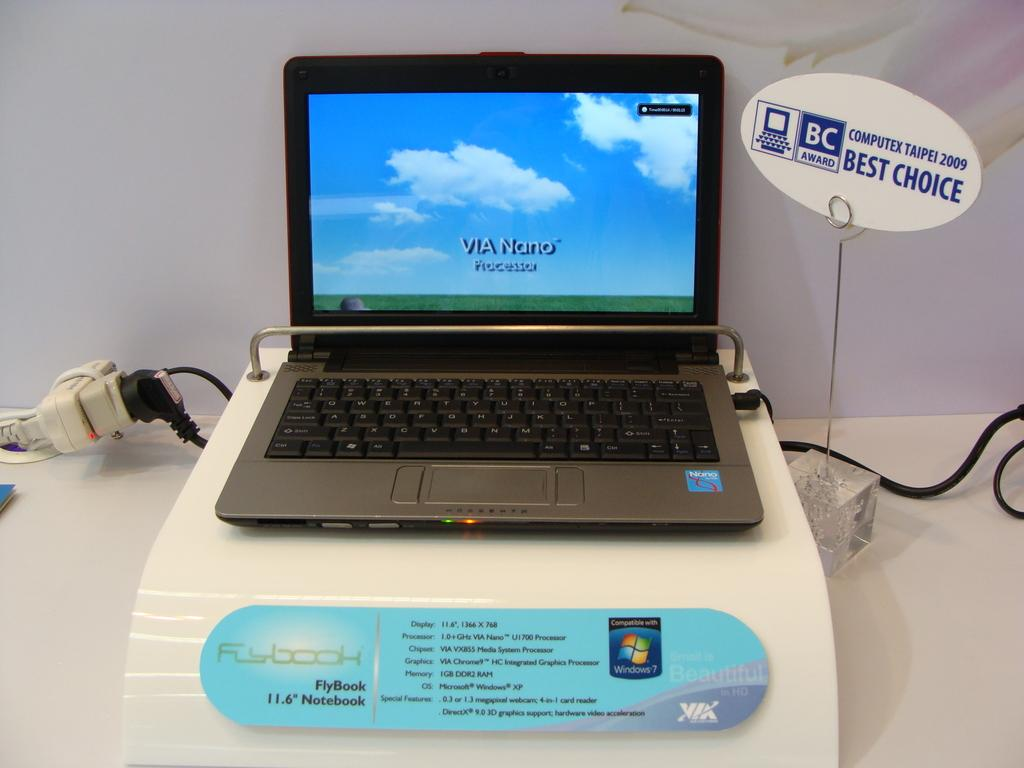<image>
Offer a succinct explanation of the picture presented. A Flybook notebook that comes with a Via Nano processor. 